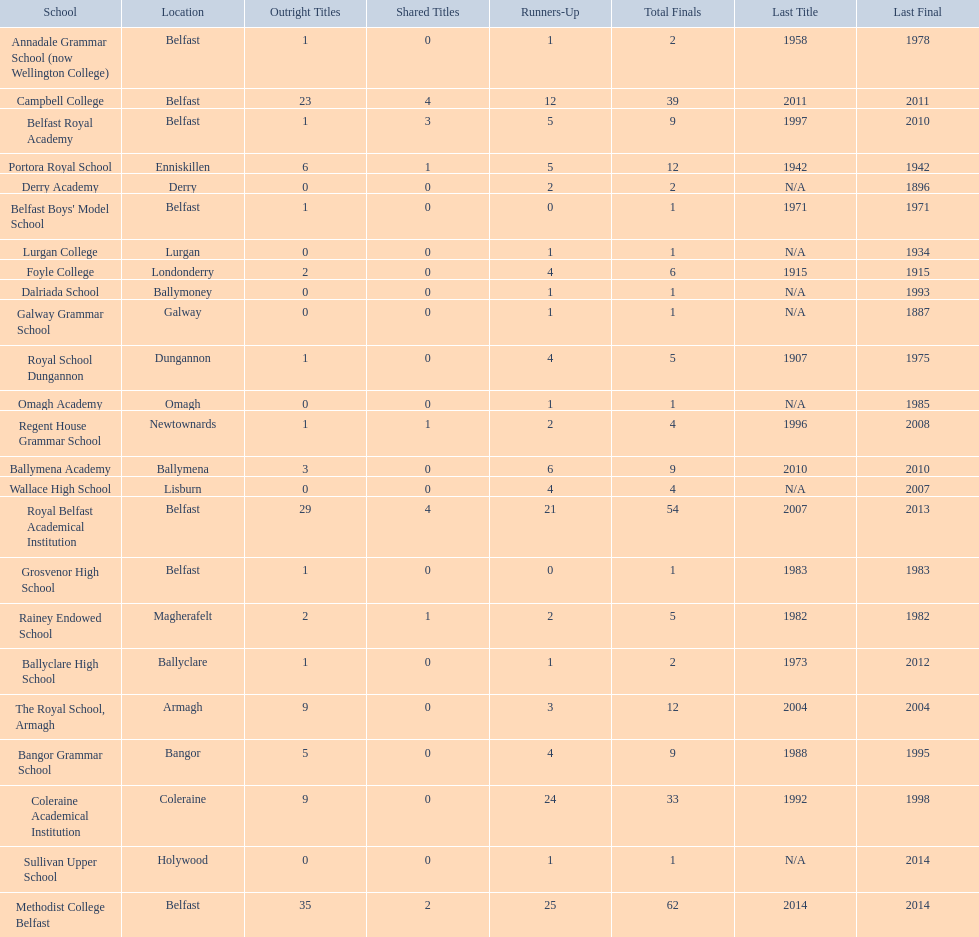Which colleges participated in the ulster's schools' cup? Methodist College Belfast, Royal Belfast Academical Institution, Campbell College, Coleraine Academical Institution, The Royal School, Armagh, Portora Royal School, Bangor Grammar School, Ballymena Academy, Rainey Endowed School, Foyle College, Belfast Royal Academy, Regent House Grammar School, Royal School Dungannon, Annadale Grammar School (now Wellington College), Ballyclare High School, Belfast Boys' Model School, Grosvenor High School, Wallace High School, Derry Academy, Dalriada School, Galway Grammar School, Lurgan College, Omagh Academy, Sullivan Upper School. Of these, which are from belfast? Methodist College Belfast, Royal Belfast Academical Institution, Campbell College, Belfast Royal Academy, Annadale Grammar School (now Wellington College), Belfast Boys' Model School, Grosvenor High School. Of these, which have more than 20 outright titles? Methodist College Belfast, Royal Belfast Academical Institution, Campbell College. Which of these have the fewest runners-up? Campbell College. 